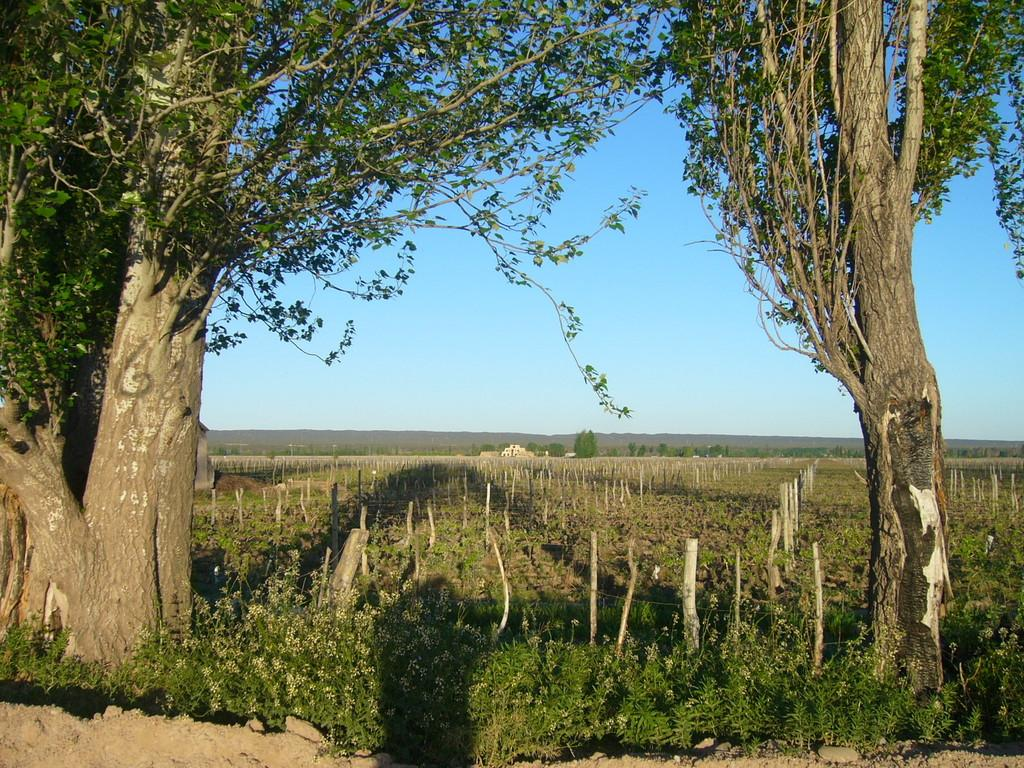What type of vegetation can be seen in the image? There are trees in the image. What is the color of the trees in the image? The trees are green in color. What can be seen in the background of the image? The sky is visible in the background of the image. What colors are present in the sky in the image? The sky is blue and white in color. How does the anger of the trees manifest in the image? There is no indication of anger in the image, as trees do not have emotions. 